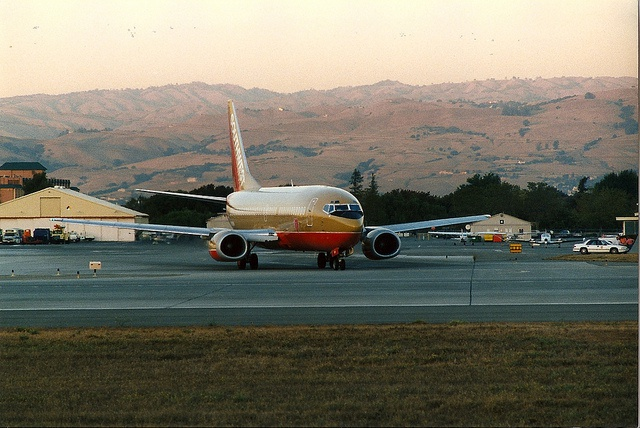Describe the objects in this image and their specific colors. I can see airplane in beige, black, darkgray, olive, and lightgray tones, car in beige, black, lightgray, darkgray, and gray tones, truck in beige, black, gray, and darkgray tones, truck in beige, black, olive, and gray tones, and car in beige, darkgray, gray, and lightgray tones in this image. 